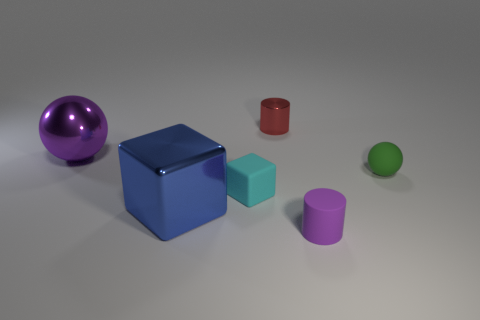Add 4 small green matte spheres. How many objects exist? 10 Add 3 big rubber cylinders. How many big rubber cylinders exist? 3 Subtract 0 cyan balls. How many objects are left? 6 Subtract all cyan cubes. Subtract all large cubes. How many objects are left? 4 Add 4 purple metal spheres. How many purple metal spheres are left? 5 